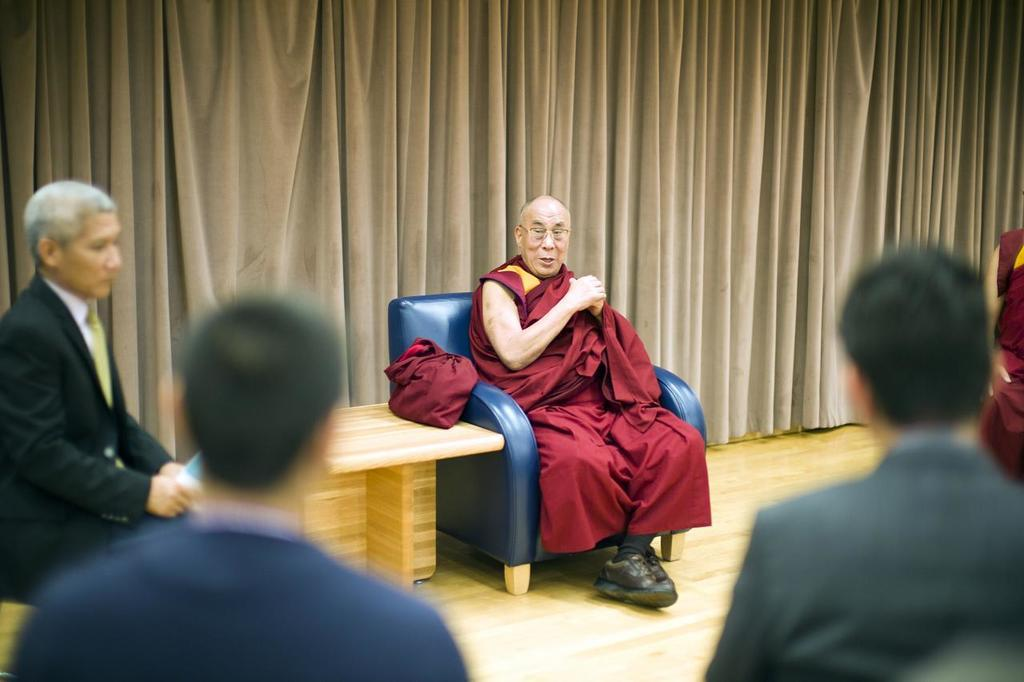What are the people in the image doing? The people in the image are sitting. Can you describe the old man in the image? The old man is sitting on a blue color sofa. What furniture is present in the image? There is a table in the image. What can be seen in the background of the image? There are curtains in the background of the image. What flavor of soap is the old man using in the image? There is no soap present in the image, and therefore no flavor can be determined. 